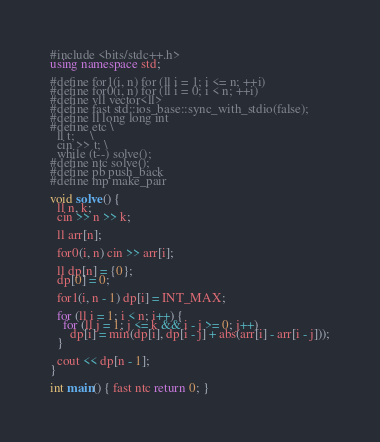Convert code to text. <code><loc_0><loc_0><loc_500><loc_500><_C++_>#include <bits/stdc++.h>
using namespace std;

#define for1(i, n) for (ll i = 1; i <= n; ++i)
#define for0(i, n) for (ll i = 0; i < n; ++i)
#define vll vector<ll>
#define fast std::ios_base::sync_with_stdio(false);
#define ll long long int
#define etc \
  ll t;     \
  cin >> t; \
  while (t--) solve();
#define ntc solve();
#define pb push_back
#define mp make_pair

void solve() {
  ll n, k;
  cin >> n >> k;

  ll arr[n];

  for0(i, n) cin >> arr[i];

  ll dp[n] = {0};
  dp[0] = 0;

  for1(i, n - 1) dp[i] = INT_MAX;

  for (ll i = 1; i < n; i++) {
    for (ll j = 1; j <= k && i - j >= 0; j++)
      dp[i] = min(dp[i], dp[i - j] + abs(arr[i] - arr[i - j]));
  }

  cout << dp[n - 1];
}

int main() { fast ntc return 0; }</code> 